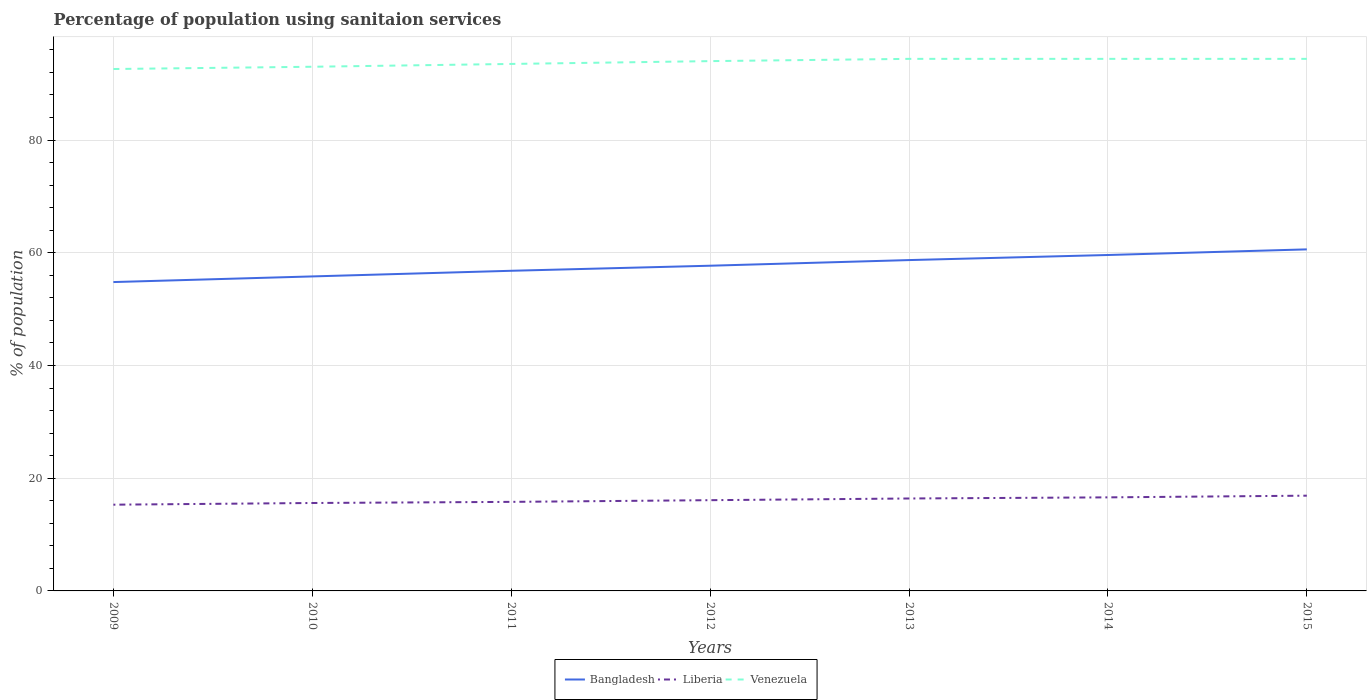Across all years, what is the maximum percentage of population using sanitaion services in Liberia?
Ensure brevity in your answer.  15.3. What is the total percentage of population using sanitaion services in Liberia in the graph?
Provide a short and direct response. -0.8. What is the difference between the highest and the second highest percentage of population using sanitaion services in Venezuela?
Keep it short and to the point. 1.8. What is the difference between the highest and the lowest percentage of population using sanitaion services in Bangladesh?
Offer a very short reply. 3. How many years are there in the graph?
Your response must be concise. 7. Does the graph contain grids?
Provide a short and direct response. Yes. How many legend labels are there?
Offer a very short reply. 3. How are the legend labels stacked?
Provide a succinct answer. Horizontal. What is the title of the graph?
Make the answer very short. Percentage of population using sanitaion services. What is the label or title of the Y-axis?
Your answer should be compact. % of population. What is the % of population of Bangladesh in 2009?
Give a very brief answer. 54.8. What is the % of population in Liberia in 2009?
Make the answer very short. 15.3. What is the % of population of Venezuela in 2009?
Ensure brevity in your answer.  92.6. What is the % of population of Bangladesh in 2010?
Your answer should be very brief. 55.8. What is the % of population of Liberia in 2010?
Give a very brief answer. 15.6. What is the % of population of Venezuela in 2010?
Ensure brevity in your answer.  93. What is the % of population of Bangladesh in 2011?
Make the answer very short. 56.8. What is the % of population of Venezuela in 2011?
Give a very brief answer. 93.5. What is the % of population in Bangladesh in 2012?
Your response must be concise. 57.7. What is the % of population in Venezuela in 2012?
Your answer should be very brief. 94. What is the % of population of Bangladesh in 2013?
Your answer should be compact. 58.7. What is the % of population in Liberia in 2013?
Offer a very short reply. 16.4. What is the % of population in Venezuela in 2013?
Provide a short and direct response. 94.4. What is the % of population of Bangladesh in 2014?
Offer a terse response. 59.6. What is the % of population in Liberia in 2014?
Your response must be concise. 16.6. What is the % of population of Venezuela in 2014?
Your response must be concise. 94.4. What is the % of population in Bangladesh in 2015?
Make the answer very short. 60.6. What is the % of population of Venezuela in 2015?
Give a very brief answer. 94.4. Across all years, what is the maximum % of population in Bangladesh?
Your answer should be very brief. 60.6. Across all years, what is the maximum % of population in Venezuela?
Make the answer very short. 94.4. Across all years, what is the minimum % of population in Bangladesh?
Ensure brevity in your answer.  54.8. Across all years, what is the minimum % of population in Venezuela?
Provide a short and direct response. 92.6. What is the total % of population of Bangladesh in the graph?
Provide a succinct answer. 404. What is the total % of population of Liberia in the graph?
Provide a short and direct response. 112.7. What is the total % of population of Venezuela in the graph?
Give a very brief answer. 656.3. What is the difference between the % of population of Bangladesh in 2009 and that in 2010?
Make the answer very short. -1. What is the difference between the % of population in Liberia in 2009 and that in 2010?
Your response must be concise. -0.3. What is the difference between the % of population in Bangladesh in 2009 and that in 2011?
Your answer should be very brief. -2. What is the difference between the % of population in Venezuela in 2009 and that in 2011?
Your answer should be very brief. -0.9. What is the difference between the % of population in Bangladesh in 2009 and that in 2012?
Provide a short and direct response. -2.9. What is the difference between the % of population in Venezuela in 2009 and that in 2013?
Give a very brief answer. -1.8. What is the difference between the % of population of Liberia in 2009 and that in 2014?
Your answer should be very brief. -1.3. What is the difference between the % of population in Liberia in 2009 and that in 2015?
Ensure brevity in your answer.  -1.6. What is the difference between the % of population of Bangladesh in 2010 and that in 2011?
Provide a short and direct response. -1. What is the difference between the % of population of Liberia in 2010 and that in 2011?
Offer a very short reply. -0.2. What is the difference between the % of population of Venezuela in 2010 and that in 2011?
Your answer should be compact. -0.5. What is the difference between the % of population in Liberia in 2010 and that in 2012?
Keep it short and to the point. -0.5. What is the difference between the % of population of Bangladesh in 2010 and that in 2013?
Keep it short and to the point. -2.9. What is the difference between the % of population of Liberia in 2010 and that in 2013?
Your response must be concise. -0.8. What is the difference between the % of population in Venezuela in 2010 and that in 2013?
Ensure brevity in your answer.  -1.4. What is the difference between the % of population of Bangladesh in 2010 and that in 2014?
Your answer should be compact. -3.8. What is the difference between the % of population in Liberia in 2010 and that in 2014?
Provide a succinct answer. -1. What is the difference between the % of population of Venezuela in 2010 and that in 2014?
Ensure brevity in your answer.  -1.4. What is the difference between the % of population of Bangladesh in 2010 and that in 2015?
Your answer should be compact. -4.8. What is the difference between the % of population of Liberia in 2010 and that in 2015?
Keep it short and to the point. -1.3. What is the difference between the % of population of Bangladesh in 2011 and that in 2012?
Ensure brevity in your answer.  -0.9. What is the difference between the % of population in Liberia in 2011 and that in 2012?
Make the answer very short. -0.3. What is the difference between the % of population of Venezuela in 2011 and that in 2012?
Make the answer very short. -0.5. What is the difference between the % of population in Venezuela in 2011 and that in 2013?
Your answer should be very brief. -0.9. What is the difference between the % of population in Liberia in 2011 and that in 2014?
Your response must be concise. -0.8. What is the difference between the % of population in Venezuela in 2011 and that in 2014?
Provide a short and direct response. -0.9. What is the difference between the % of population in Bangladesh in 2011 and that in 2015?
Your answer should be very brief. -3.8. What is the difference between the % of population of Venezuela in 2011 and that in 2015?
Offer a very short reply. -0.9. What is the difference between the % of population in Liberia in 2012 and that in 2013?
Provide a short and direct response. -0.3. What is the difference between the % of population of Venezuela in 2012 and that in 2013?
Provide a short and direct response. -0.4. What is the difference between the % of population of Bangladesh in 2012 and that in 2015?
Keep it short and to the point. -2.9. What is the difference between the % of population of Liberia in 2012 and that in 2015?
Give a very brief answer. -0.8. What is the difference between the % of population of Venezuela in 2012 and that in 2015?
Give a very brief answer. -0.4. What is the difference between the % of population in Bangladesh in 2013 and that in 2014?
Keep it short and to the point. -0.9. What is the difference between the % of population in Liberia in 2013 and that in 2014?
Your response must be concise. -0.2. What is the difference between the % of population of Venezuela in 2013 and that in 2014?
Ensure brevity in your answer.  0. What is the difference between the % of population of Liberia in 2013 and that in 2015?
Give a very brief answer. -0.5. What is the difference between the % of population of Venezuela in 2013 and that in 2015?
Provide a succinct answer. 0. What is the difference between the % of population of Bangladesh in 2014 and that in 2015?
Ensure brevity in your answer.  -1. What is the difference between the % of population of Liberia in 2014 and that in 2015?
Keep it short and to the point. -0.3. What is the difference between the % of population in Venezuela in 2014 and that in 2015?
Offer a very short reply. 0. What is the difference between the % of population in Bangladesh in 2009 and the % of population in Liberia in 2010?
Ensure brevity in your answer.  39.2. What is the difference between the % of population in Bangladesh in 2009 and the % of population in Venezuela in 2010?
Make the answer very short. -38.2. What is the difference between the % of population of Liberia in 2009 and the % of population of Venezuela in 2010?
Your answer should be very brief. -77.7. What is the difference between the % of population of Bangladesh in 2009 and the % of population of Venezuela in 2011?
Ensure brevity in your answer.  -38.7. What is the difference between the % of population of Liberia in 2009 and the % of population of Venezuela in 2011?
Your answer should be very brief. -78.2. What is the difference between the % of population in Bangladesh in 2009 and the % of population in Liberia in 2012?
Provide a short and direct response. 38.7. What is the difference between the % of population in Bangladesh in 2009 and the % of population in Venezuela in 2012?
Make the answer very short. -39.2. What is the difference between the % of population of Liberia in 2009 and the % of population of Venezuela in 2012?
Your answer should be compact. -78.7. What is the difference between the % of population in Bangladesh in 2009 and the % of population in Liberia in 2013?
Provide a succinct answer. 38.4. What is the difference between the % of population of Bangladesh in 2009 and the % of population of Venezuela in 2013?
Your response must be concise. -39.6. What is the difference between the % of population of Liberia in 2009 and the % of population of Venezuela in 2013?
Your response must be concise. -79.1. What is the difference between the % of population of Bangladesh in 2009 and the % of population of Liberia in 2014?
Give a very brief answer. 38.2. What is the difference between the % of population in Bangladesh in 2009 and the % of population in Venezuela in 2014?
Offer a terse response. -39.6. What is the difference between the % of population in Liberia in 2009 and the % of population in Venezuela in 2014?
Your answer should be compact. -79.1. What is the difference between the % of population in Bangladesh in 2009 and the % of population in Liberia in 2015?
Make the answer very short. 37.9. What is the difference between the % of population of Bangladesh in 2009 and the % of population of Venezuela in 2015?
Your answer should be compact. -39.6. What is the difference between the % of population in Liberia in 2009 and the % of population in Venezuela in 2015?
Your answer should be very brief. -79.1. What is the difference between the % of population of Bangladesh in 2010 and the % of population of Venezuela in 2011?
Provide a short and direct response. -37.7. What is the difference between the % of population in Liberia in 2010 and the % of population in Venezuela in 2011?
Your answer should be very brief. -77.9. What is the difference between the % of population of Bangladesh in 2010 and the % of population of Liberia in 2012?
Keep it short and to the point. 39.7. What is the difference between the % of population in Bangladesh in 2010 and the % of population in Venezuela in 2012?
Provide a succinct answer. -38.2. What is the difference between the % of population of Liberia in 2010 and the % of population of Venezuela in 2012?
Offer a terse response. -78.4. What is the difference between the % of population in Bangladesh in 2010 and the % of population in Liberia in 2013?
Make the answer very short. 39.4. What is the difference between the % of population in Bangladesh in 2010 and the % of population in Venezuela in 2013?
Provide a succinct answer. -38.6. What is the difference between the % of population of Liberia in 2010 and the % of population of Venezuela in 2013?
Ensure brevity in your answer.  -78.8. What is the difference between the % of population in Bangladesh in 2010 and the % of population in Liberia in 2014?
Your answer should be very brief. 39.2. What is the difference between the % of population of Bangladesh in 2010 and the % of population of Venezuela in 2014?
Provide a short and direct response. -38.6. What is the difference between the % of population of Liberia in 2010 and the % of population of Venezuela in 2014?
Offer a terse response. -78.8. What is the difference between the % of population of Bangladesh in 2010 and the % of population of Liberia in 2015?
Keep it short and to the point. 38.9. What is the difference between the % of population in Bangladesh in 2010 and the % of population in Venezuela in 2015?
Give a very brief answer. -38.6. What is the difference between the % of population of Liberia in 2010 and the % of population of Venezuela in 2015?
Make the answer very short. -78.8. What is the difference between the % of population in Bangladesh in 2011 and the % of population in Liberia in 2012?
Your answer should be compact. 40.7. What is the difference between the % of population in Bangladesh in 2011 and the % of population in Venezuela in 2012?
Your response must be concise. -37.2. What is the difference between the % of population of Liberia in 2011 and the % of population of Venezuela in 2012?
Keep it short and to the point. -78.2. What is the difference between the % of population in Bangladesh in 2011 and the % of population in Liberia in 2013?
Offer a terse response. 40.4. What is the difference between the % of population in Bangladesh in 2011 and the % of population in Venezuela in 2013?
Offer a very short reply. -37.6. What is the difference between the % of population of Liberia in 2011 and the % of population of Venezuela in 2013?
Your answer should be very brief. -78.6. What is the difference between the % of population of Bangladesh in 2011 and the % of population of Liberia in 2014?
Make the answer very short. 40.2. What is the difference between the % of population in Bangladesh in 2011 and the % of population in Venezuela in 2014?
Ensure brevity in your answer.  -37.6. What is the difference between the % of population in Liberia in 2011 and the % of population in Venezuela in 2014?
Provide a succinct answer. -78.6. What is the difference between the % of population of Bangladesh in 2011 and the % of population of Liberia in 2015?
Your response must be concise. 39.9. What is the difference between the % of population of Bangladesh in 2011 and the % of population of Venezuela in 2015?
Your answer should be very brief. -37.6. What is the difference between the % of population of Liberia in 2011 and the % of population of Venezuela in 2015?
Provide a succinct answer. -78.6. What is the difference between the % of population in Bangladesh in 2012 and the % of population in Liberia in 2013?
Ensure brevity in your answer.  41.3. What is the difference between the % of population of Bangladesh in 2012 and the % of population of Venezuela in 2013?
Your answer should be compact. -36.7. What is the difference between the % of population of Liberia in 2012 and the % of population of Venezuela in 2013?
Your answer should be compact. -78.3. What is the difference between the % of population in Bangladesh in 2012 and the % of population in Liberia in 2014?
Offer a terse response. 41.1. What is the difference between the % of population of Bangladesh in 2012 and the % of population of Venezuela in 2014?
Your response must be concise. -36.7. What is the difference between the % of population of Liberia in 2012 and the % of population of Venezuela in 2014?
Your answer should be compact. -78.3. What is the difference between the % of population in Bangladesh in 2012 and the % of population in Liberia in 2015?
Make the answer very short. 40.8. What is the difference between the % of population in Bangladesh in 2012 and the % of population in Venezuela in 2015?
Ensure brevity in your answer.  -36.7. What is the difference between the % of population in Liberia in 2012 and the % of population in Venezuela in 2015?
Provide a succinct answer. -78.3. What is the difference between the % of population of Bangladesh in 2013 and the % of population of Liberia in 2014?
Provide a succinct answer. 42.1. What is the difference between the % of population of Bangladesh in 2013 and the % of population of Venezuela in 2014?
Your response must be concise. -35.7. What is the difference between the % of population in Liberia in 2013 and the % of population in Venezuela in 2014?
Provide a succinct answer. -78. What is the difference between the % of population of Bangladesh in 2013 and the % of population of Liberia in 2015?
Make the answer very short. 41.8. What is the difference between the % of population of Bangladesh in 2013 and the % of population of Venezuela in 2015?
Provide a short and direct response. -35.7. What is the difference between the % of population in Liberia in 2013 and the % of population in Venezuela in 2015?
Provide a short and direct response. -78. What is the difference between the % of population in Bangladesh in 2014 and the % of population in Liberia in 2015?
Offer a terse response. 42.7. What is the difference between the % of population of Bangladesh in 2014 and the % of population of Venezuela in 2015?
Provide a short and direct response. -34.8. What is the difference between the % of population of Liberia in 2014 and the % of population of Venezuela in 2015?
Keep it short and to the point. -77.8. What is the average % of population in Bangladesh per year?
Ensure brevity in your answer.  57.71. What is the average % of population in Venezuela per year?
Your answer should be compact. 93.76. In the year 2009, what is the difference between the % of population in Bangladesh and % of population in Liberia?
Ensure brevity in your answer.  39.5. In the year 2009, what is the difference between the % of population of Bangladesh and % of population of Venezuela?
Your answer should be very brief. -37.8. In the year 2009, what is the difference between the % of population in Liberia and % of population in Venezuela?
Your answer should be compact. -77.3. In the year 2010, what is the difference between the % of population in Bangladesh and % of population in Liberia?
Keep it short and to the point. 40.2. In the year 2010, what is the difference between the % of population of Bangladesh and % of population of Venezuela?
Make the answer very short. -37.2. In the year 2010, what is the difference between the % of population in Liberia and % of population in Venezuela?
Provide a succinct answer. -77.4. In the year 2011, what is the difference between the % of population of Bangladesh and % of population of Liberia?
Your answer should be compact. 41. In the year 2011, what is the difference between the % of population of Bangladesh and % of population of Venezuela?
Offer a terse response. -36.7. In the year 2011, what is the difference between the % of population of Liberia and % of population of Venezuela?
Your answer should be very brief. -77.7. In the year 2012, what is the difference between the % of population in Bangladesh and % of population in Liberia?
Offer a terse response. 41.6. In the year 2012, what is the difference between the % of population in Bangladesh and % of population in Venezuela?
Make the answer very short. -36.3. In the year 2012, what is the difference between the % of population in Liberia and % of population in Venezuela?
Ensure brevity in your answer.  -77.9. In the year 2013, what is the difference between the % of population of Bangladesh and % of population of Liberia?
Provide a short and direct response. 42.3. In the year 2013, what is the difference between the % of population in Bangladesh and % of population in Venezuela?
Your answer should be very brief. -35.7. In the year 2013, what is the difference between the % of population of Liberia and % of population of Venezuela?
Offer a terse response. -78. In the year 2014, what is the difference between the % of population of Bangladesh and % of population of Liberia?
Your answer should be compact. 43. In the year 2014, what is the difference between the % of population of Bangladesh and % of population of Venezuela?
Make the answer very short. -34.8. In the year 2014, what is the difference between the % of population in Liberia and % of population in Venezuela?
Keep it short and to the point. -77.8. In the year 2015, what is the difference between the % of population in Bangladesh and % of population in Liberia?
Offer a very short reply. 43.7. In the year 2015, what is the difference between the % of population in Bangladesh and % of population in Venezuela?
Keep it short and to the point. -33.8. In the year 2015, what is the difference between the % of population of Liberia and % of population of Venezuela?
Ensure brevity in your answer.  -77.5. What is the ratio of the % of population of Bangladesh in 2009 to that in 2010?
Your answer should be compact. 0.98. What is the ratio of the % of population in Liberia in 2009 to that in 2010?
Keep it short and to the point. 0.98. What is the ratio of the % of population in Bangladesh in 2009 to that in 2011?
Ensure brevity in your answer.  0.96. What is the ratio of the % of population of Liberia in 2009 to that in 2011?
Offer a very short reply. 0.97. What is the ratio of the % of population in Venezuela in 2009 to that in 2011?
Offer a very short reply. 0.99. What is the ratio of the % of population of Bangladesh in 2009 to that in 2012?
Your answer should be compact. 0.95. What is the ratio of the % of population of Liberia in 2009 to that in 2012?
Provide a succinct answer. 0.95. What is the ratio of the % of population of Venezuela in 2009 to that in 2012?
Your response must be concise. 0.99. What is the ratio of the % of population in Bangladesh in 2009 to that in 2013?
Your answer should be compact. 0.93. What is the ratio of the % of population in Liberia in 2009 to that in 2013?
Your answer should be compact. 0.93. What is the ratio of the % of population in Venezuela in 2009 to that in 2013?
Offer a terse response. 0.98. What is the ratio of the % of population in Bangladesh in 2009 to that in 2014?
Offer a very short reply. 0.92. What is the ratio of the % of population of Liberia in 2009 to that in 2014?
Give a very brief answer. 0.92. What is the ratio of the % of population of Venezuela in 2009 to that in 2014?
Your answer should be compact. 0.98. What is the ratio of the % of population in Bangladesh in 2009 to that in 2015?
Provide a short and direct response. 0.9. What is the ratio of the % of population in Liberia in 2009 to that in 2015?
Your response must be concise. 0.91. What is the ratio of the % of population in Venezuela in 2009 to that in 2015?
Provide a short and direct response. 0.98. What is the ratio of the % of population of Bangladesh in 2010 to that in 2011?
Your answer should be very brief. 0.98. What is the ratio of the % of population in Liberia in 2010 to that in 2011?
Provide a succinct answer. 0.99. What is the ratio of the % of population in Bangladesh in 2010 to that in 2012?
Ensure brevity in your answer.  0.97. What is the ratio of the % of population in Liberia in 2010 to that in 2012?
Offer a terse response. 0.97. What is the ratio of the % of population of Venezuela in 2010 to that in 2012?
Offer a terse response. 0.99. What is the ratio of the % of population in Bangladesh in 2010 to that in 2013?
Offer a very short reply. 0.95. What is the ratio of the % of population in Liberia in 2010 to that in 2013?
Offer a very short reply. 0.95. What is the ratio of the % of population of Venezuela in 2010 to that in 2013?
Provide a short and direct response. 0.99. What is the ratio of the % of population in Bangladesh in 2010 to that in 2014?
Your response must be concise. 0.94. What is the ratio of the % of population of Liberia in 2010 to that in 2014?
Keep it short and to the point. 0.94. What is the ratio of the % of population of Venezuela in 2010 to that in 2014?
Your response must be concise. 0.99. What is the ratio of the % of population of Bangladesh in 2010 to that in 2015?
Ensure brevity in your answer.  0.92. What is the ratio of the % of population of Venezuela in 2010 to that in 2015?
Offer a very short reply. 0.99. What is the ratio of the % of population in Bangladesh in 2011 to that in 2012?
Provide a succinct answer. 0.98. What is the ratio of the % of population in Liberia in 2011 to that in 2012?
Keep it short and to the point. 0.98. What is the ratio of the % of population in Bangladesh in 2011 to that in 2013?
Make the answer very short. 0.97. What is the ratio of the % of population in Liberia in 2011 to that in 2013?
Offer a very short reply. 0.96. What is the ratio of the % of population of Venezuela in 2011 to that in 2013?
Ensure brevity in your answer.  0.99. What is the ratio of the % of population of Bangladesh in 2011 to that in 2014?
Ensure brevity in your answer.  0.95. What is the ratio of the % of population of Liberia in 2011 to that in 2014?
Provide a succinct answer. 0.95. What is the ratio of the % of population in Bangladesh in 2011 to that in 2015?
Make the answer very short. 0.94. What is the ratio of the % of population of Liberia in 2011 to that in 2015?
Provide a succinct answer. 0.93. What is the ratio of the % of population in Liberia in 2012 to that in 2013?
Make the answer very short. 0.98. What is the ratio of the % of population in Venezuela in 2012 to that in 2013?
Offer a terse response. 1. What is the ratio of the % of population of Bangladesh in 2012 to that in 2014?
Your answer should be compact. 0.97. What is the ratio of the % of population of Liberia in 2012 to that in 2014?
Ensure brevity in your answer.  0.97. What is the ratio of the % of population in Bangladesh in 2012 to that in 2015?
Make the answer very short. 0.95. What is the ratio of the % of population of Liberia in 2012 to that in 2015?
Offer a terse response. 0.95. What is the ratio of the % of population in Bangladesh in 2013 to that in 2014?
Give a very brief answer. 0.98. What is the ratio of the % of population in Bangladesh in 2013 to that in 2015?
Your answer should be compact. 0.97. What is the ratio of the % of population of Liberia in 2013 to that in 2015?
Keep it short and to the point. 0.97. What is the ratio of the % of population in Bangladesh in 2014 to that in 2015?
Provide a short and direct response. 0.98. What is the ratio of the % of population in Liberia in 2014 to that in 2015?
Provide a succinct answer. 0.98. What is the difference between the highest and the second highest % of population in Bangladesh?
Make the answer very short. 1. What is the difference between the highest and the second highest % of population in Venezuela?
Your answer should be compact. 0. What is the difference between the highest and the lowest % of population of Bangladesh?
Offer a terse response. 5.8. What is the difference between the highest and the lowest % of population in Liberia?
Give a very brief answer. 1.6. What is the difference between the highest and the lowest % of population in Venezuela?
Keep it short and to the point. 1.8. 